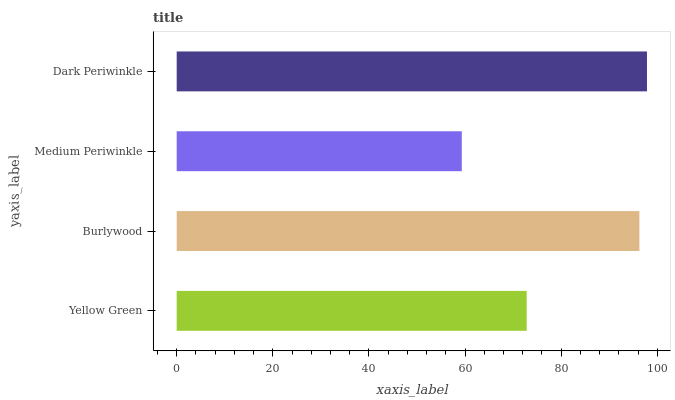Is Medium Periwinkle the minimum?
Answer yes or no. Yes. Is Dark Periwinkle the maximum?
Answer yes or no. Yes. Is Burlywood the minimum?
Answer yes or no. No. Is Burlywood the maximum?
Answer yes or no. No. Is Burlywood greater than Yellow Green?
Answer yes or no. Yes. Is Yellow Green less than Burlywood?
Answer yes or no. Yes. Is Yellow Green greater than Burlywood?
Answer yes or no. No. Is Burlywood less than Yellow Green?
Answer yes or no. No. Is Burlywood the high median?
Answer yes or no. Yes. Is Yellow Green the low median?
Answer yes or no. Yes. Is Dark Periwinkle the high median?
Answer yes or no. No. Is Dark Periwinkle the low median?
Answer yes or no. No. 